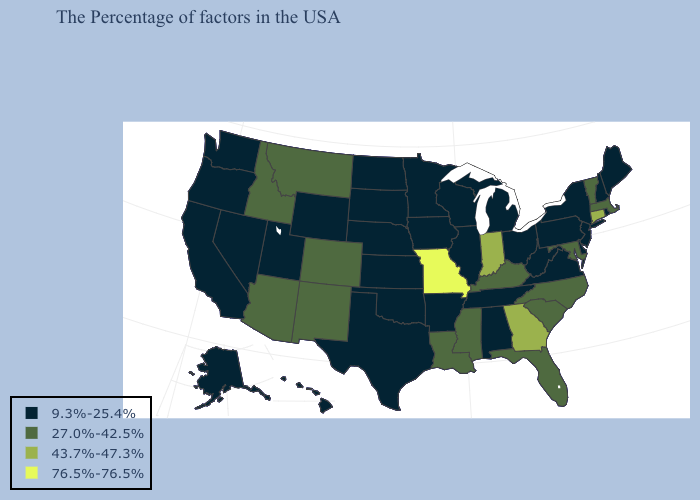What is the highest value in the USA?
Concise answer only. 76.5%-76.5%. What is the value of Colorado?
Be succinct. 27.0%-42.5%. What is the highest value in the West ?
Keep it brief. 27.0%-42.5%. Which states have the highest value in the USA?
Keep it brief. Missouri. Does Wyoming have the same value as Rhode Island?
Give a very brief answer. Yes. Name the states that have a value in the range 27.0%-42.5%?
Quick response, please. Massachusetts, Vermont, Maryland, North Carolina, South Carolina, Florida, Kentucky, Mississippi, Louisiana, Colorado, New Mexico, Montana, Arizona, Idaho. Among the states that border South Carolina , which have the highest value?
Concise answer only. Georgia. Among the states that border New Hampshire , which have the lowest value?
Be succinct. Maine. Does Virginia have the lowest value in the South?
Short answer required. Yes. Name the states that have a value in the range 76.5%-76.5%?
Short answer required. Missouri. What is the value of Massachusetts?
Quick response, please. 27.0%-42.5%. What is the value of Maryland?
Concise answer only. 27.0%-42.5%. What is the value of Louisiana?
Concise answer only. 27.0%-42.5%. Among the states that border North Dakota , does Minnesota have the lowest value?
Give a very brief answer. Yes. Name the states that have a value in the range 76.5%-76.5%?
Short answer required. Missouri. 